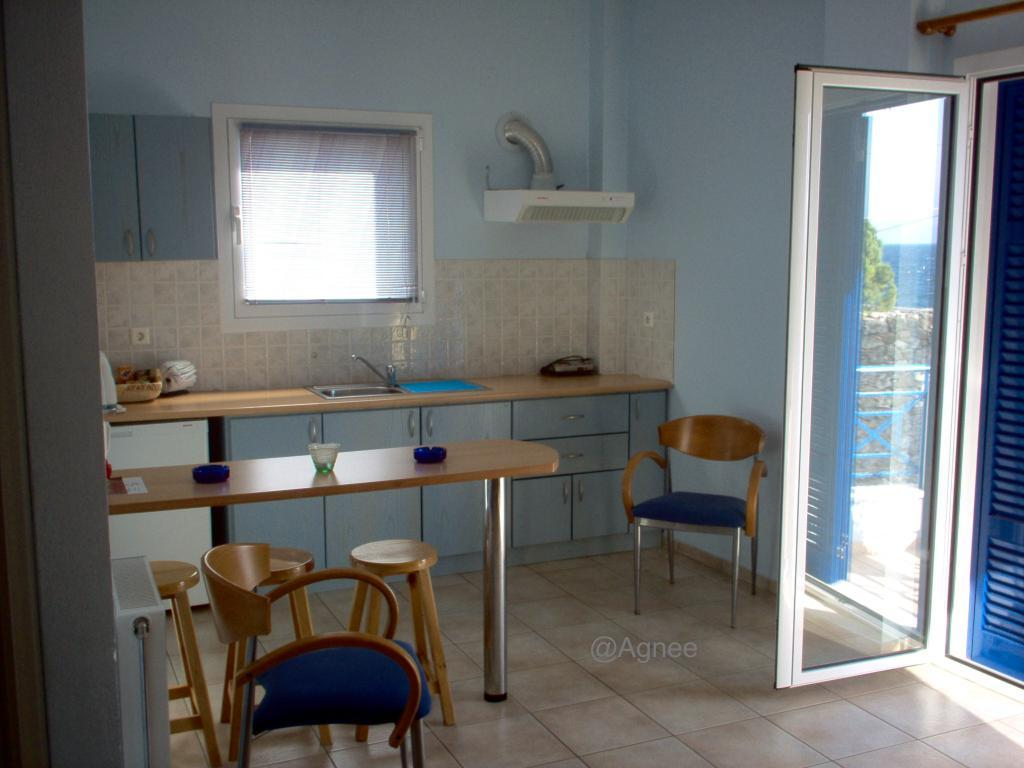What type of furniture is present in the image? There is a table, chairs, and stools in the image. What surface can be used for food preparation or serving in the image? There is a counter top in the image. What is used for washing in the image? There is a sink in the image. Where is the door located in the image? The door is on the right side of the image. What color are the walls in the image? The walls are in blue color. What is a source of natural light in the image? There is a window in the image. How many kittens are sitting on the shelf in the image? There is no shelf or kittens present in the image. What type of polish is used on the table in the image? There is no mention of polish or any specific treatment on the table in the image. 